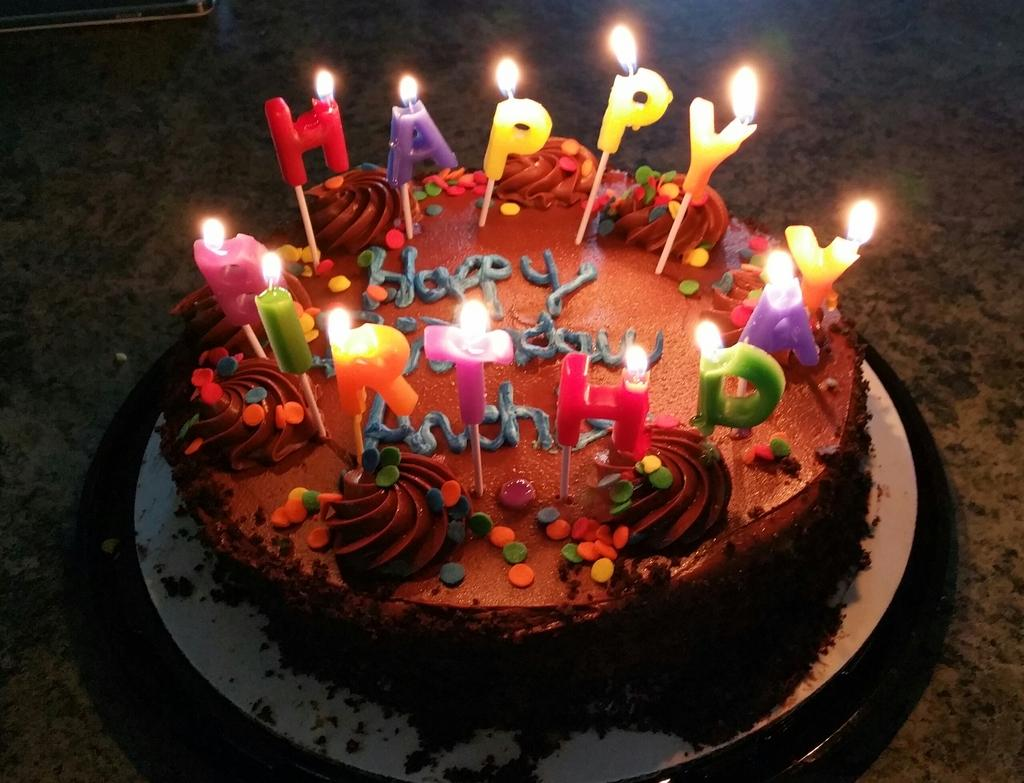What is the main subject of the image? There is a birthday cake in the image. What is placed on top of the cake? Candles are placed on the cake. What color is the surface on which the cake is placed? The cake is on a black color surface. How would you describe the overall lighting or brightness in the image? The background of the image is dark. What type of yarn is being used to decorate the cake in the image? There is no yarn present in the image; the cake is decorated with candles. Can you tell me the relation between the people in the image? There are no people present in the image, only a birthday cake with candles on a black surface against a dark background. 